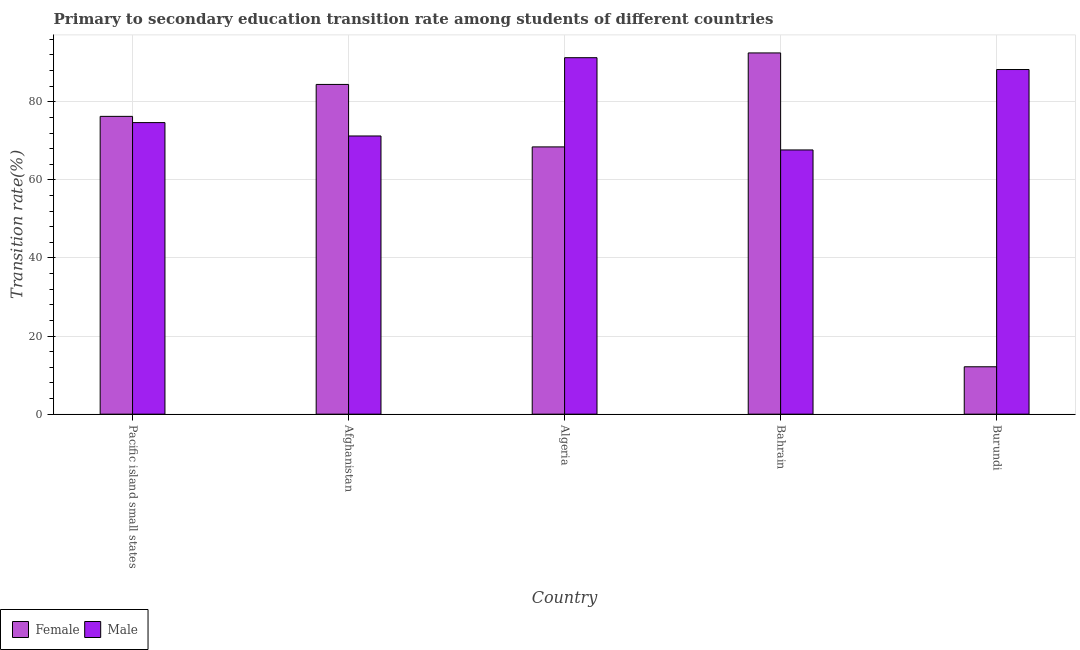What is the label of the 4th group of bars from the left?
Provide a short and direct response. Bahrain. What is the transition rate among female students in Burundi?
Keep it short and to the point. 12.14. Across all countries, what is the maximum transition rate among female students?
Keep it short and to the point. 92.52. Across all countries, what is the minimum transition rate among male students?
Provide a succinct answer. 67.68. In which country was the transition rate among female students maximum?
Your answer should be compact. Bahrain. In which country was the transition rate among female students minimum?
Provide a short and direct response. Burundi. What is the total transition rate among male students in the graph?
Offer a very short reply. 393.19. What is the difference between the transition rate among female students in Afghanistan and that in Pacific island small states?
Offer a very short reply. 8.18. What is the difference between the transition rate among female students in Afghanistan and the transition rate among male students in Algeria?
Your response must be concise. -6.85. What is the average transition rate among male students per country?
Your answer should be compact. 78.64. What is the difference between the transition rate among female students and transition rate among male students in Pacific island small states?
Keep it short and to the point. 1.59. What is the ratio of the transition rate among male students in Algeria to that in Burundi?
Make the answer very short. 1.03. Is the difference between the transition rate among female students in Algeria and Pacific island small states greater than the difference between the transition rate among male students in Algeria and Pacific island small states?
Make the answer very short. No. What is the difference between the highest and the second highest transition rate among female students?
Your answer should be compact. 8.07. What is the difference between the highest and the lowest transition rate among male students?
Provide a short and direct response. 23.63. What does the 2nd bar from the right in Afghanistan represents?
Your answer should be compact. Female. How many bars are there?
Ensure brevity in your answer.  10. Are all the bars in the graph horizontal?
Offer a terse response. No. What is the difference between two consecutive major ticks on the Y-axis?
Provide a succinct answer. 20. Where does the legend appear in the graph?
Give a very brief answer. Bottom left. How many legend labels are there?
Offer a very short reply. 2. What is the title of the graph?
Give a very brief answer. Primary to secondary education transition rate among students of different countries. Does "Highest 20% of population" appear as one of the legend labels in the graph?
Make the answer very short. No. What is the label or title of the Y-axis?
Provide a short and direct response. Transition rate(%). What is the Transition rate(%) in Female in Pacific island small states?
Keep it short and to the point. 76.28. What is the Transition rate(%) in Male in Pacific island small states?
Offer a very short reply. 74.68. What is the Transition rate(%) of Female in Afghanistan?
Ensure brevity in your answer.  84.46. What is the Transition rate(%) of Male in Afghanistan?
Offer a very short reply. 71.26. What is the Transition rate(%) of Female in Algeria?
Offer a terse response. 68.46. What is the Transition rate(%) in Male in Algeria?
Your answer should be very brief. 91.3. What is the Transition rate(%) in Female in Bahrain?
Offer a very short reply. 92.52. What is the Transition rate(%) of Male in Bahrain?
Your answer should be compact. 67.68. What is the Transition rate(%) in Female in Burundi?
Your response must be concise. 12.14. What is the Transition rate(%) in Male in Burundi?
Offer a terse response. 88.27. Across all countries, what is the maximum Transition rate(%) in Female?
Your answer should be very brief. 92.52. Across all countries, what is the maximum Transition rate(%) of Male?
Provide a succinct answer. 91.3. Across all countries, what is the minimum Transition rate(%) in Female?
Your answer should be compact. 12.14. Across all countries, what is the minimum Transition rate(%) in Male?
Give a very brief answer. 67.68. What is the total Transition rate(%) of Female in the graph?
Offer a terse response. 333.85. What is the total Transition rate(%) of Male in the graph?
Make the answer very short. 393.19. What is the difference between the Transition rate(%) of Female in Pacific island small states and that in Afghanistan?
Offer a very short reply. -8.18. What is the difference between the Transition rate(%) of Male in Pacific island small states and that in Afghanistan?
Provide a short and direct response. 3.42. What is the difference between the Transition rate(%) of Female in Pacific island small states and that in Algeria?
Your response must be concise. 7.82. What is the difference between the Transition rate(%) in Male in Pacific island small states and that in Algeria?
Your answer should be very brief. -16.62. What is the difference between the Transition rate(%) in Female in Pacific island small states and that in Bahrain?
Provide a short and direct response. -16.25. What is the difference between the Transition rate(%) of Male in Pacific island small states and that in Bahrain?
Offer a very short reply. 7. What is the difference between the Transition rate(%) of Female in Pacific island small states and that in Burundi?
Offer a very short reply. 64.14. What is the difference between the Transition rate(%) in Male in Pacific island small states and that in Burundi?
Keep it short and to the point. -13.59. What is the difference between the Transition rate(%) in Female in Afghanistan and that in Algeria?
Your answer should be compact. 16. What is the difference between the Transition rate(%) in Male in Afghanistan and that in Algeria?
Provide a short and direct response. -20.05. What is the difference between the Transition rate(%) in Female in Afghanistan and that in Bahrain?
Keep it short and to the point. -8.07. What is the difference between the Transition rate(%) of Male in Afghanistan and that in Bahrain?
Your answer should be compact. 3.58. What is the difference between the Transition rate(%) of Female in Afghanistan and that in Burundi?
Give a very brief answer. 72.32. What is the difference between the Transition rate(%) of Male in Afghanistan and that in Burundi?
Your response must be concise. -17.02. What is the difference between the Transition rate(%) in Female in Algeria and that in Bahrain?
Your answer should be compact. -24.07. What is the difference between the Transition rate(%) in Male in Algeria and that in Bahrain?
Your response must be concise. 23.63. What is the difference between the Transition rate(%) in Female in Algeria and that in Burundi?
Ensure brevity in your answer.  56.32. What is the difference between the Transition rate(%) of Male in Algeria and that in Burundi?
Provide a short and direct response. 3.03. What is the difference between the Transition rate(%) of Female in Bahrain and that in Burundi?
Your answer should be compact. 80.39. What is the difference between the Transition rate(%) in Male in Bahrain and that in Burundi?
Your answer should be very brief. -20.6. What is the difference between the Transition rate(%) of Female in Pacific island small states and the Transition rate(%) of Male in Afghanistan?
Ensure brevity in your answer.  5.02. What is the difference between the Transition rate(%) in Female in Pacific island small states and the Transition rate(%) in Male in Algeria?
Offer a very short reply. -15.03. What is the difference between the Transition rate(%) in Female in Pacific island small states and the Transition rate(%) in Male in Bahrain?
Give a very brief answer. 8.6. What is the difference between the Transition rate(%) of Female in Pacific island small states and the Transition rate(%) of Male in Burundi?
Provide a short and direct response. -12. What is the difference between the Transition rate(%) in Female in Afghanistan and the Transition rate(%) in Male in Algeria?
Offer a terse response. -6.85. What is the difference between the Transition rate(%) in Female in Afghanistan and the Transition rate(%) in Male in Bahrain?
Keep it short and to the point. 16.78. What is the difference between the Transition rate(%) in Female in Afghanistan and the Transition rate(%) in Male in Burundi?
Offer a terse response. -3.82. What is the difference between the Transition rate(%) of Female in Algeria and the Transition rate(%) of Male in Bahrain?
Keep it short and to the point. 0.78. What is the difference between the Transition rate(%) in Female in Algeria and the Transition rate(%) in Male in Burundi?
Your answer should be very brief. -19.82. What is the difference between the Transition rate(%) of Female in Bahrain and the Transition rate(%) of Male in Burundi?
Keep it short and to the point. 4.25. What is the average Transition rate(%) of Female per country?
Make the answer very short. 66.77. What is the average Transition rate(%) in Male per country?
Your answer should be compact. 78.64. What is the difference between the Transition rate(%) in Female and Transition rate(%) in Male in Pacific island small states?
Ensure brevity in your answer.  1.59. What is the difference between the Transition rate(%) of Female and Transition rate(%) of Male in Afghanistan?
Your answer should be compact. 13.2. What is the difference between the Transition rate(%) in Female and Transition rate(%) in Male in Algeria?
Ensure brevity in your answer.  -22.85. What is the difference between the Transition rate(%) of Female and Transition rate(%) of Male in Bahrain?
Provide a succinct answer. 24.85. What is the difference between the Transition rate(%) in Female and Transition rate(%) in Male in Burundi?
Your answer should be compact. -76.14. What is the ratio of the Transition rate(%) of Female in Pacific island small states to that in Afghanistan?
Offer a very short reply. 0.9. What is the ratio of the Transition rate(%) in Male in Pacific island small states to that in Afghanistan?
Your answer should be very brief. 1.05. What is the ratio of the Transition rate(%) of Female in Pacific island small states to that in Algeria?
Ensure brevity in your answer.  1.11. What is the ratio of the Transition rate(%) of Male in Pacific island small states to that in Algeria?
Your answer should be compact. 0.82. What is the ratio of the Transition rate(%) of Female in Pacific island small states to that in Bahrain?
Provide a short and direct response. 0.82. What is the ratio of the Transition rate(%) of Male in Pacific island small states to that in Bahrain?
Your response must be concise. 1.1. What is the ratio of the Transition rate(%) of Female in Pacific island small states to that in Burundi?
Keep it short and to the point. 6.28. What is the ratio of the Transition rate(%) in Male in Pacific island small states to that in Burundi?
Keep it short and to the point. 0.85. What is the ratio of the Transition rate(%) in Female in Afghanistan to that in Algeria?
Keep it short and to the point. 1.23. What is the ratio of the Transition rate(%) of Male in Afghanistan to that in Algeria?
Offer a very short reply. 0.78. What is the ratio of the Transition rate(%) in Female in Afghanistan to that in Bahrain?
Your answer should be compact. 0.91. What is the ratio of the Transition rate(%) of Male in Afghanistan to that in Bahrain?
Your response must be concise. 1.05. What is the ratio of the Transition rate(%) of Female in Afghanistan to that in Burundi?
Make the answer very short. 6.96. What is the ratio of the Transition rate(%) of Male in Afghanistan to that in Burundi?
Offer a very short reply. 0.81. What is the ratio of the Transition rate(%) of Female in Algeria to that in Bahrain?
Keep it short and to the point. 0.74. What is the ratio of the Transition rate(%) of Male in Algeria to that in Bahrain?
Ensure brevity in your answer.  1.35. What is the ratio of the Transition rate(%) of Female in Algeria to that in Burundi?
Make the answer very short. 5.64. What is the ratio of the Transition rate(%) in Male in Algeria to that in Burundi?
Offer a terse response. 1.03. What is the ratio of the Transition rate(%) in Female in Bahrain to that in Burundi?
Offer a very short reply. 7.62. What is the ratio of the Transition rate(%) in Male in Bahrain to that in Burundi?
Your response must be concise. 0.77. What is the difference between the highest and the second highest Transition rate(%) of Female?
Ensure brevity in your answer.  8.07. What is the difference between the highest and the second highest Transition rate(%) of Male?
Offer a very short reply. 3.03. What is the difference between the highest and the lowest Transition rate(%) of Female?
Offer a terse response. 80.39. What is the difference between the highest and the lowest Transition rate(%) of Male?
Give a very brief answer. 23.63. 